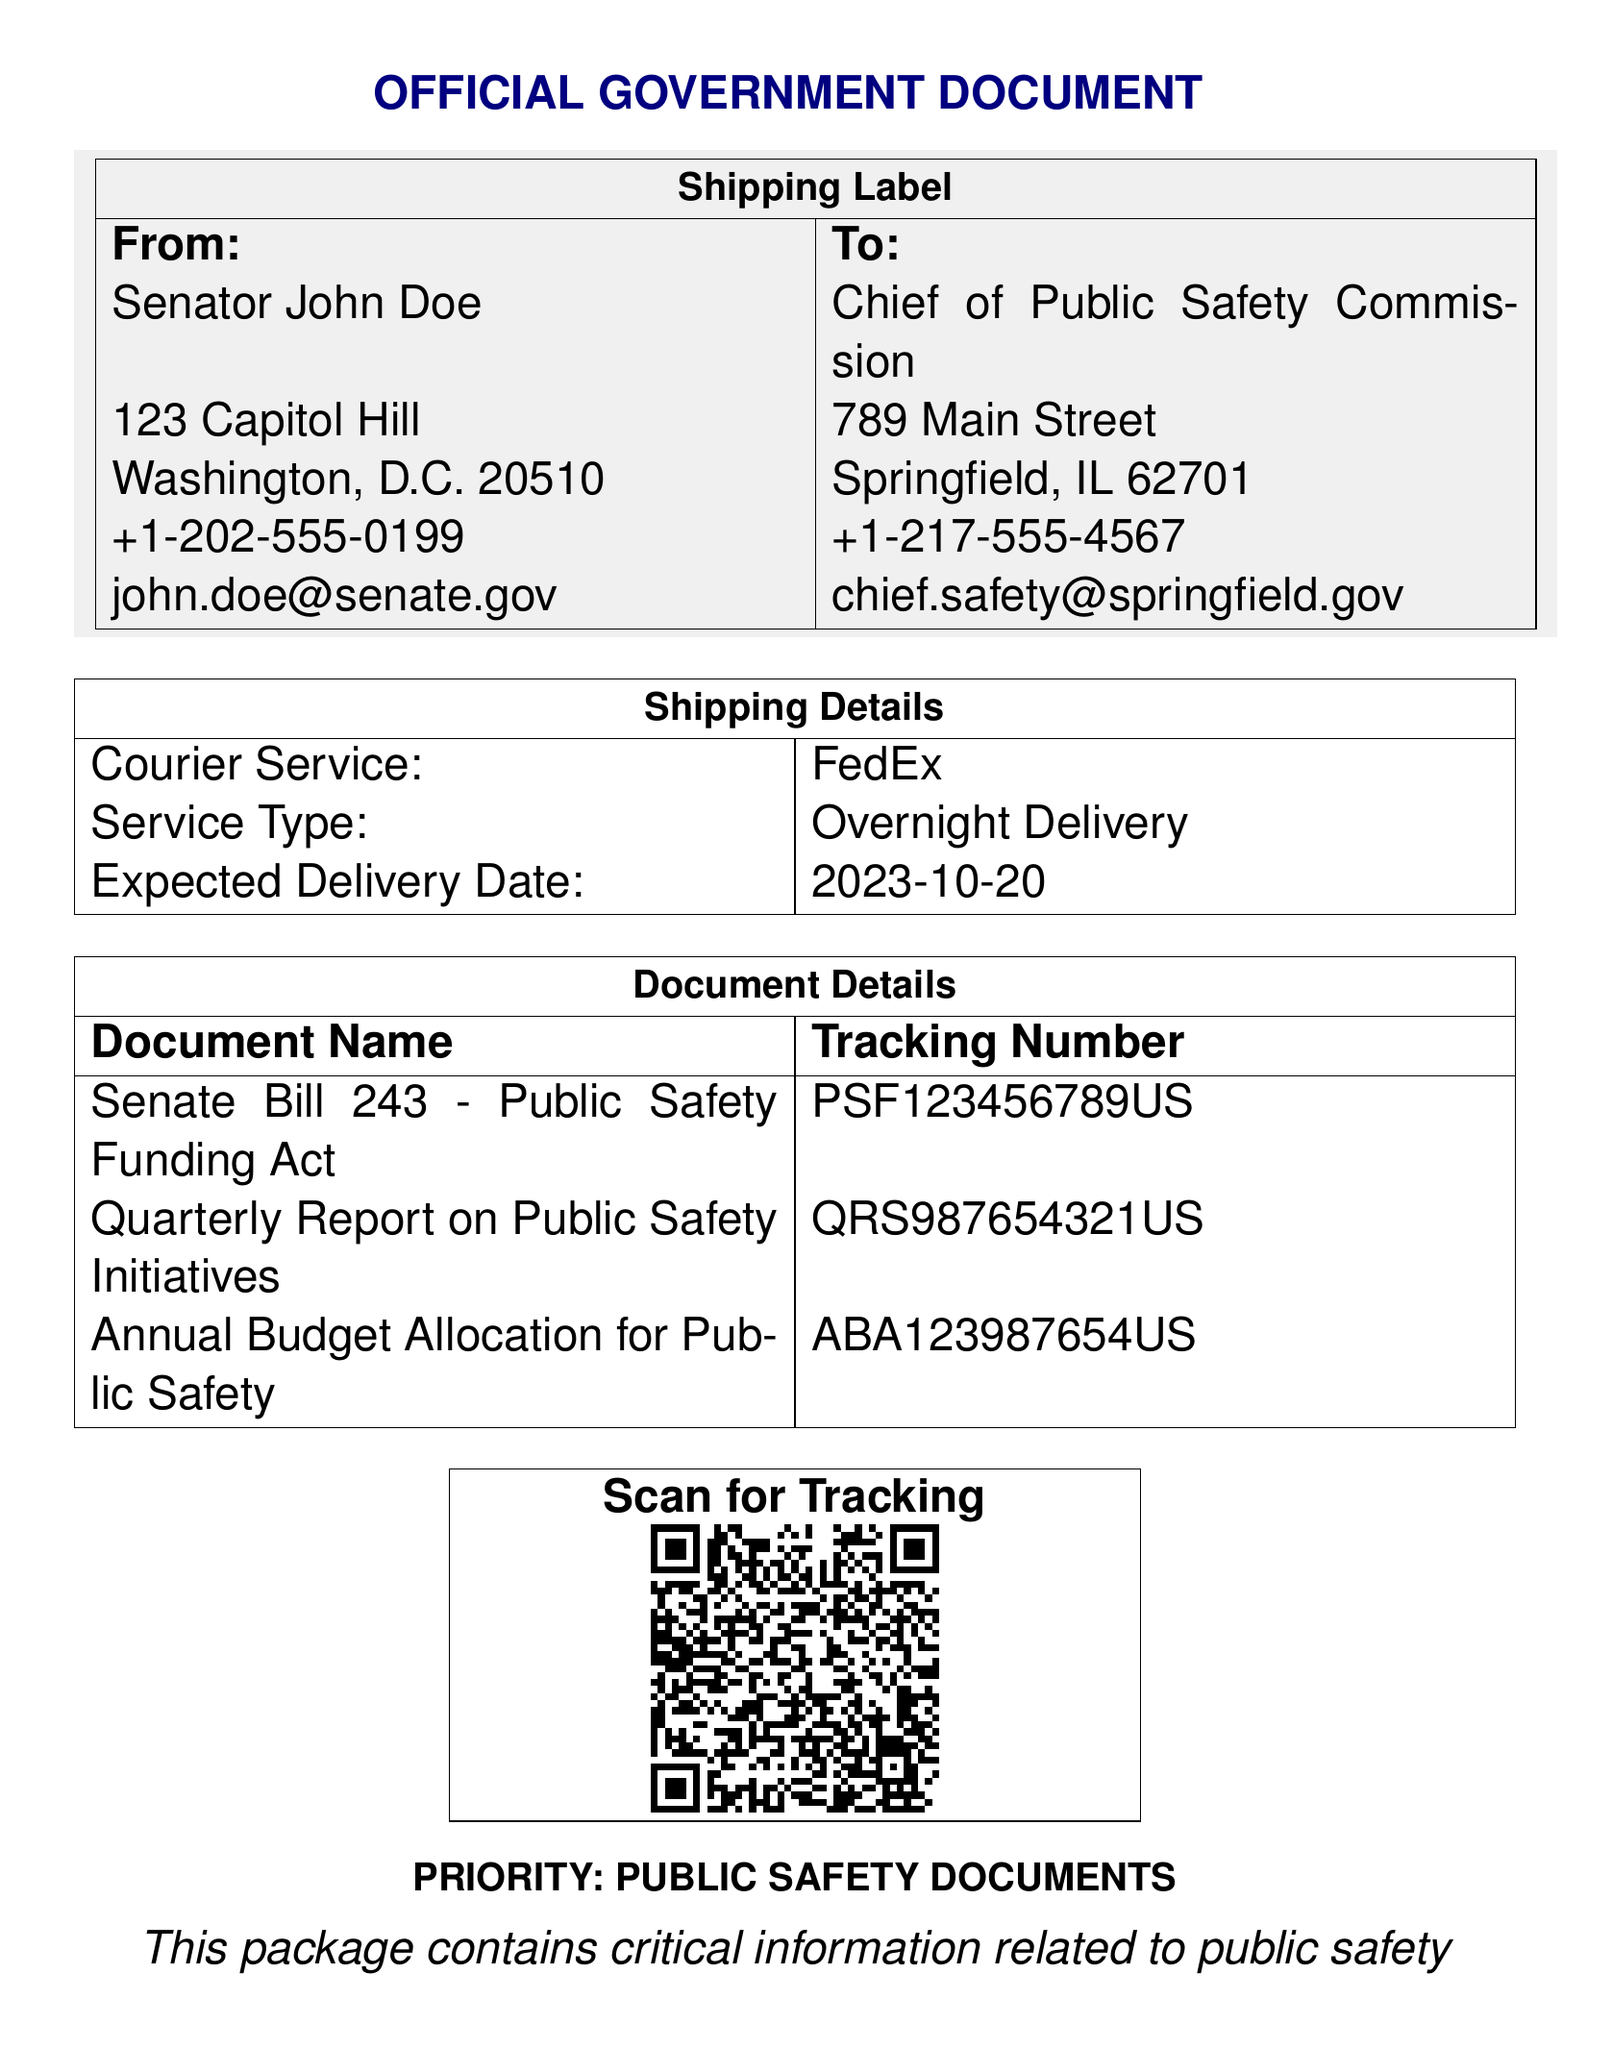What is the sender's name? The sender's name is listed in the "From" section of the document.
Answer: Senator John Doe What is the recipient's email address? The recipient's email address is provided in the "To" section of the document.
Answer: chief.safety@springfield.gov What is the tracking number for the Senate Bill 243? The tracking number is specified in the "Document Details" section associated with the Senate Bill 243.
Answer: PSF123456789US What is the expected delivery date? The expected delivery date is mentioned in the "Shipping Details" section of the document.
Answer: 2023-10-20 Which courier service is used? The courier service name is stated in the "Shipping Details" section.
Answer: FedEx How many documents are included in the package? The number of documents can be counted from the "Document Details" section of the document.
Answer: 3 What type of service is being used for delivery? The service type is listed in the "Shipping Details" section of the document.
Answer: Overnight Delivery What is the priority level of this shipment? The priority level is mentioned at the bottom of the document.
Answer: PUBLIC SAFETY DOCUMENTS What is the address of the sender? The sender's address is found in the "From" section of the document.
Answer: 123 Capitol Hill, Washington, D.C. 20510 